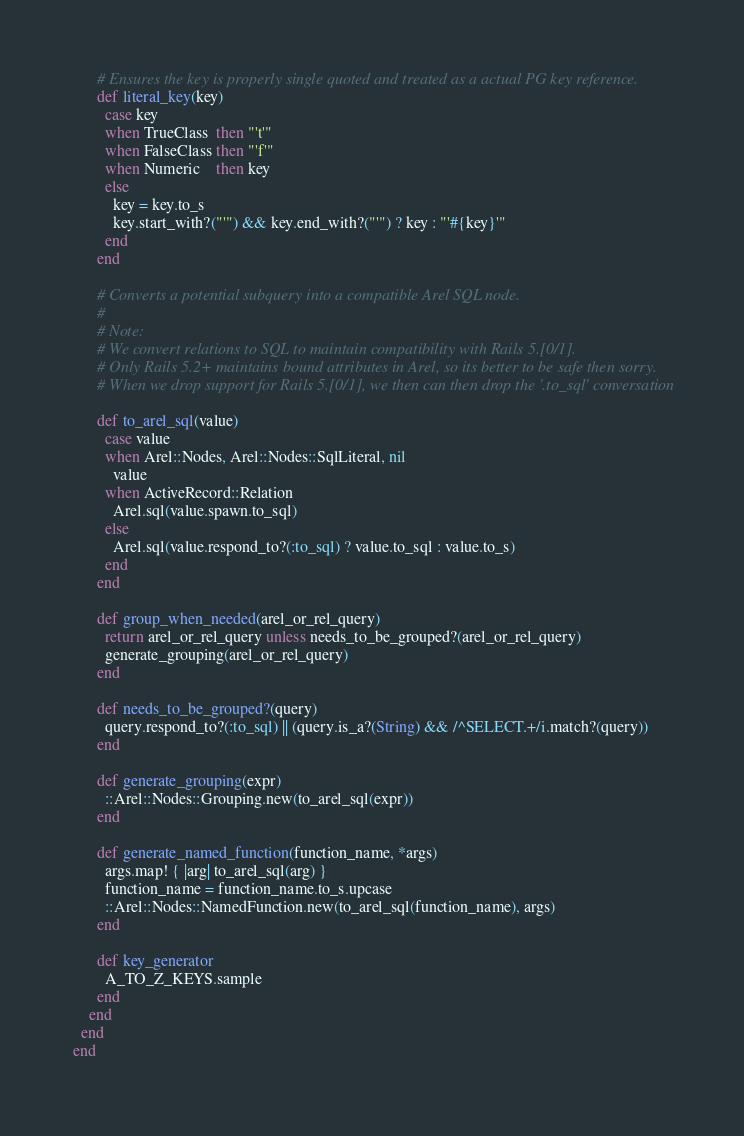<code> <loc_0><loc_0><loc_500><loc_500><_Ruby_>      # Ensures the key is properly single quoted and treated as a actual PG key reference.
      def literal_key(key)
        case key
        when TrueClass  then "'t'"
        when FalseClass then "'f'"
        when Numeric    then key
        else
          key = key.to_s
          key.start_with?("'") && key.end_with?("'") ? key : "'#{key}'"
        end
      end

      # Converts a potential subquery into a compatible Arel SQL node.
      #
      # Note:
      # We convert relations to SQL to maintain compatibility with Rails 5.[0/1].
      # Only Rails 5.2+ maintains bound attributes in Arel, so its better to be safe then sorry.
      # When we drop support for Rails 5.[0/1], we then can then drop the '.to_sql' conversation

      def to_arel_sql(value)
        case value
        when Arel::Nodes, Arel::Nodes::SqlLiteral, nil
          value
        when ActiveRecord::Relation
          Arel.sql(value.spawn.to_sql)
        else
          Arel.sql(value.respond_to?(:to_sql) ? value.to_sql : value.to_s)
        end
      end

      def group_when_needed(arel_or_rel_query)
        return arel_or_rel_query unless needs_to_be_grouped?(arel_or_rel_query)
        generate_grouping(arel_or_rel_query)
      end

      def needs_to_be_grouped?(query)
        query.respond_to?(:to_sql) || (query.is_a?(String) && /^SELECT.+/i.match?(query))
      end

      def generate_grouping(expr)
        ::Arel::Nodes::Grouping.new(to_arel_sql(expr))
      end

      def generate_named_function(function_name, *args)
        args.map! { |arg| to_arel_sql(arg) }
        function_name = function_name.to_s.upcase
        ::Arel::Nodes::NamedFunction.new(to_arel_sql(function_name), args)
      end

      def key_generator
        A_TO_Z_KEYS.sample
      end
    end
  end
end
</code> 